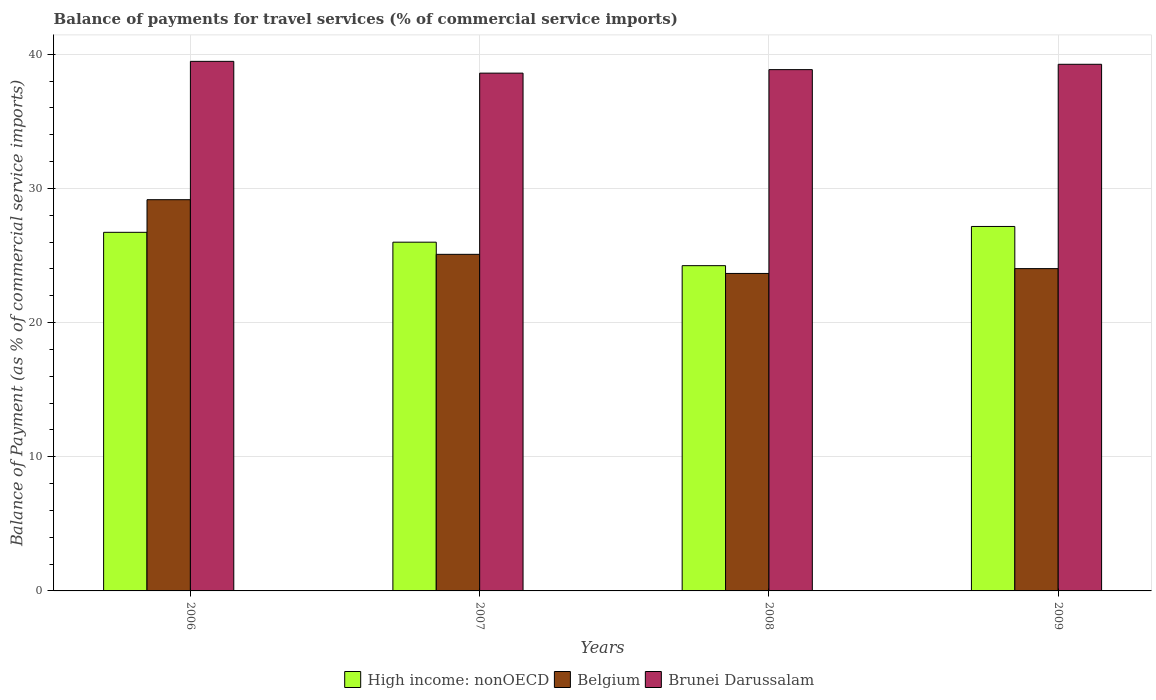How many different coloured bars are there?
Offer a terse response. 3. Are the number of bars on each tick of the X-axis equal?
Provide a succinct answer. Yes. How many bars are there on the 2nd tick from the right?
Make the answer very short. 3. What is the label of the 2nd group of bars from the left?
Keep it short and to the point. 2007. What is the balance of payments for travel services in Belgium in 2006?
Provide a succinct answer. 29.16. Across all years, what is the maximum balance of payments for travel services in High income: nonOECD?
Your answer should be very brief. 27.17. Across all years, what is the minimum balance of payments for travel services in Belgium?
Your response must be concise. 23.66. In which year was the balance of payments for travel services in Belgium minimum?
Your answer should be very brief. 2008. What is the total balance of payments for travel services in Brunei Darussalam in the graph?
Offer a very short reply. 156.18. What is the difference between the balance of payments for travel services in Brunei Darussalam in 2008 and that in 2009?
Your response must be concise. -0.4. What is the difference between the balance of payments for travel services in Belgium in 2008 and the balance of payments for travel services in Brunei Darussalam in 2009?
Keep it short and to the point. -15.59. What is the average balance of payments for travel services in Belgium per year?
Your answer should be compact. 25.48. In the year 2008, what is the difference between the balance of payments for travel services in Belgium and balance of payments for travel services in Brunei Darussalam?
Your answer should be compact. -15.19. What is the ratio of the balance of payments for travel services in Belgium in 2008 to that in 2009?
Offer a terse response. 0.99. Is the balance of payments for travel services in High income: nonOECD in 2007 less than that in 2009?
Offer a terse response. Yes. Is the difference between the balance of payments for travel services in Belgium in 2006 and 2009 greater than the difference between the balance of payments for travel services in Brunei Darussalam in 2006 and 2009?
Ensure brevity in your answer.  Yes. What is the difference between the highest and the second highest balance of payments for travel services in Brunei Darussalam?
Your answer should be very brief. 0.22. What is the difference between the highest and the lowest balance of payments for travel services in Brunei Darussalam?
Provide a succinct answer. 0.88. In how many years, is the balance of payments for travel services in High income: nonOECD greater than the average balance of payments for travel services in High income: nonOECD taken over all years?
Ensure brevity in your answer.  2. What does the 1st bar from the left in 2007 represents?
Your response must be concise. High income: nonOECD. What does the 3rd bar from the right in 2008 represents?
Provide a succinct answer. High income: nonOECD. Is it the case that in every year, the sum of the balance of payments for travel services in Brunei Darussalam and balance of payments for travel services in High income: nonOECD is greater than the balance of payments for travel services in Belgium?
Offer a very short reply. Yes. Are all the bars in the graph horizontal?
Ensure brevity in your answer.  No. How many years are there in the graph?
Give a very brief answer. 4. Where does the legend appear in the graph?
Keep it short and to the point. Bottom center. How many legend labels are there?
Provide a short and direct response. 3. What is the title of the graph?
Give a very brief answer. Balance of payments for travel services (% of commercial service imports). Does "Central African Republic" appear as one of the legend labels in the graph?
Give a very brief answer. No. What is the label or title of the Y-axis?
Your answer should be compact. Balance of Payment (as % of commercial service imports). What is the Balance of Payment (as % of commercial service imports) in High income: nonOECD in 2006?
Offer a very short reply. 26.73. What is the Balance of Payment (as % of commercial service imports) in Belgium in 2006?
Keep it short and to the point. 29.16. What is the Balance of Payment (as % of commercial service imports) of Brunei Darussalam in 2006?
Your response must be concise. 39.47. What is the Balance of Payment (as % of commercial service imports) of High income: nonOECD in 2007?
Give a very brief answer. 25.99. What is the Balance of Payment (as % of commercial service imports) in Belgium in 2007?
Your answer should be very brief. 25.09. What is the Balance of Payment (as % of commercial service imports) of Brunei Darussalam in 2007?
Your answer should be compact. 38.59. What is the Balance of Payment (as % of commercial service imports) of High income: nonOECD in 2008?
Give a very brief answer. 24.24. What is the Balance of Payment (as % of commercial service imports) in Belgium in 2008?
Your response must be concise. 23.66. What is the Balance of Payment (as % of commercial service imports) of Brunei Darussalam in 2008?
Your response must be concise. 38.86. What is the Balance of Payment (as % of commercial service imports) in High income: nonOECD in 2009?
Your response must be concise. 27.17. What is the Balance of Payment (as % of commercial service imports) of Belgium in 2009?
Give a very brief answer. 24.02. What is the Balance of Payment (as % of commercial service imports) of Brunei Darussalam in 2009?
Offer a very short reply. 39.25. Across all years, what is the maximum Balance of Payment (as % of commercial service imports) in High income: nonOECD?
Make the answer very short. 27.17. Across all years, what is the maximum Balance of Payment (as % of commercial service imports) in Belgium?
Your answer should be very brief. 29.16. Across all years, what is the maximum Balance of Payment (as % of commercial service imports) of Brunei Darussalam?
Provide a short and direct response. 39.47. Across all years, what is the minimum Balance of Payment (as % of commercial service imports) in High income: nonOECD?
Give a very brief answer. 24.24. Across all years, what is the minimum Balance of Payment (as % of commercial service imports) in Belgium?
Keep it short and to the point. 23.66. Across all years, what is the minimum Balance of Payment (as % of commercial service imports) of Brunei Darussalam?
Your answer should be compact. 38.59. What is the total Balance of Payment (as % of commercial service imports) in High income: nonOECD in the graph?
Your answer should be compact. 104.13. What is the total Balance of Payment (as % of commercial service imports) in Belgium in the graph?
Ensure brevity in your answer.  101.94. What is the total Balance of Payment (as % of commercial service imports) in Brunei Darussalam in the graph?
Your response must be concise. 156.18. What is the difference between the Balance of Payment (as % of commercial service imports) of High income: nonOECD in 2006 and that in 2007?
Keep it short and to the point. 0.74. What is the difference between the Balance of Payment (as % of commercial service imports) of Belgium in 2006 and that in 2007?
Your answer should be compact. 4.07. What is the difference between the Balance of Payment (as % of commercial service imports) of Brunei Darussalam in 2006 and that in 2007?
Ensure brevity in your answer.  0.88. What is the difference between the Balance of Payment (as % of commercial service imports) in High income: nonOECD in 2006 and that in 2008?
Ensure brevity in your answer.  2.48. What is the difference between the Balance of Payment (as % of commercial service imports) of Belgium in 2006 and that in 2008?
Make the answer very short. 5.5. What is the difference between the Balance of Payment (as % of commercial service imports) of Brunei Darussalam in 2006 and that in 2008?
Provide a short and direct response. 0.62. What is the difference between the Balance of Payment (as % of commercial service imports) in High income: nonOECD in 2006 and that in 2009?
Make the answer very short. -0.44. What is the difference between the Balance of Payment (as % of commercial service imports) of Belgium in 2006 and that in 2009?
Offer a very short reply. 5.14. What is the difference between the Balance of Payment (as % of commercial service imports) in Brunei Darussalam in 2006 and that in 2009?
Make the answer very short. 0.22. What is the difference between the Balance of Payment (as % of commercial service imports) in High income: nonOECD in 2007 and that in 2008?
Make the answer very short. 1.75. What is the difference between the Balance of Payment (as % of commercial service imports) of Belgium in 2007 and that in 2008?
Keep it short and to the point. 1.42. What is the difference between the Balance of Payment (as % of commercial service imports) in Brunei Darussalam in 2007 and that in 2008?
Your answer should be very brief. -0.26. What is the difference between the Balance of Payment (as % of commercial service imports) of High income: nonOECD in 2007 and that in 2009?
Keep it short and to the point. -1.17. What is the difference between the Balance of Payment (as % of commercial service imports) in Belgium in 2007 and that in 2009?
Give a very brief answer. 1.06. What is the difference between the Balance of Payment (as % of commercial service imports) of Brunei Darussalam in 2007 and that in 2009?
Ensure brevity in your answer.  -0.66. What is the difference between the Balance of Payment (as % of commercial service imports) in High income: nonOECD in 2008 and that in 2009?
Your answer should be very brief. -2.92. What is the difference between the Balance of Payment (as % of commercial service imports) of Belgium in 2008 and that in 2009?
Provide a short and direct response. -0.36. What is the difference between the Balance of Payment (as % of commercial service imports) of Brunei Darussalam in 2008 and that in 2009?
Offer a terse response. -0.4. What is the difference between the Balance of Payment (as % of commercial service imports) of High income: nonOECD in 2006 and the Balance of Payment (as % of commercial service imports) of Belgium in 2007?
Your answer should be compact. 1.64. What is the difference between the Balance of Payment (as % of commercial service imports) in High income: nonOECD in 2006 and the Balance of Payment (as % of commercial service imports) in Brunei Darussalam in 2007?
Your response must be concise. -11.87. What is the difference between the Balance of Payment (as % of commercial service imports) in Belgium in 2006 and the Balance of Payment (as % of commercial service imports) in Brunei Darussalam in 2007?
Ensure brevity in your answer.  -9.43. What is the difference between the Balance of Payment (as % of commercial service imports) in High income: nonOECD in 2006 and the Balance of Payment (as % of commercial service imports) in Belgium in 2008?
Offer a very short reply. 3.07. What is the difference between the Balance of Payment (as % of commercial service imports) of High income: nonOECD in 2006 and the Balance of Payment (as % of commercial service imports) of Brunei Darussalam in 2008?
Your answer should be compact. -12.13. What is the difference between the Balance of Payment (as % of commercial service imports) of Belgium in 2006 and the Balance of Payment (as % of commercial service imports) of Brunei Darussalam in 2008?
Provide a short and direct response. -9.69. What is the difference between the Balance of Payment (as % of commercial service imports) of High income: nonOECD in 2006 and the Balance of Payment (as % of commercial service imports) of Belgium in 2009?
Provide a succinct answer. 2.71. What is the difference between the Balance of Payment (as % of commercial service imports) in High income: nonOECD in 2006 and the Balance of Payment (as % of commercial service imports) in Brunei Darussalam in 2009?
Your answer should be compact. -12.53. What is the difference between the Balance of Payment (as % of commercial service imports) in Belgium in 2006 and the Balance of Payment (as % of commercial service imports) in Brunei Darussalam in 2009?
Keep it short and to the point. -10.09. What is the difference between the Balance of Payment (as % of commercial service imports) in High income: nonOECD in 2007 and the Balance of Payment (as % of commercial service imports) in Belgium in 2008?
Your response must be concise. 2.33. What is the difference between the Balance of Payment (as % of commercial service imports) of High income: nonOECD in 2007 and the Balance of Payment (as % of commercial service imports) of Brunei Darussalam in 2008?
Ensure brevity in your answer.  -12.86. What is the difference between the Balance of Payment (as % of commercial service imports) of Belgium in 2007 and the Balance of Payment (as % of commercial service imports) of Brunei Darussalam in 2008?
Your answer should be very brief. -13.77. What is the difference between the Balance of Payment (as % of commercial service imports) of High income: nonOECD in 2007 and the Balance of Payment (as % of commercial service imports) of Belgium in 2009?
Give a very brief answer. 1.97. What is the difference between the Balance of Payment (as % of commercial service imports) in High income: nonOECD in 2007 and the Balance of Payment (as % of commercial service imports) in Brunei Darussalam in 2009?
Ensure brevity in your answer.  -13.26. What is the difference between the Balance of Payment (as % of commercial service imports) of Belgium in 2007 and the Balance of Payment (as % of commercial service imports) of Brunei Darussalam in 2009?
Offer a very short reply. -14.17. What is the difference between the Balance of Payment (as % of commercial service imports) in High income: nonOECD in 2008 and the Balance of Payment (as % of commercial service imports) in Belgium in 2009?
Provide a succinct answer. 0.22. What is the difference between the Balance of Payment (as % of commercial service imports) of High income: nonOECD in 2008 and the Balance of Payment (as % of commercial service imports) of Brunei Darussalam in 2009?
Offer a very short reply. -15.01. What is the difference between the Balance of Payment (as % of commercial service imports) of Belgium in 2008 and the Balance of Payment (as % of commercial service imports) of Brunei Darussalam in 2009?
Provide a succinct answer. -15.59. What is the average Balance of Payment (as % of commercial service imports) of High income: nonOECD per year?
Offer a terse response. 26.03. What is the average Balance of Payment (as % of commercial service imports) of Belgium per year?
Give a very brief answer. 25.48. What is the average Balance of Payment (as % of commercial service imports) in Brunei Darussalam per year?
Your answer should be very brief. 39.04. In the year 2006, what is the difference between the Balance of Payment (as % of commercial service imports) of High income: nonOECD and Balance of Payment (as % of commercial service imports) of Belgium?
Ensure brevity in your answer.  -2.43. In the year 2006, what is the difference between the Balance of Payment (as % of commercial service imports) of High income: nonOECD and Balance of Payment (as % of commercial service imports) of Brunei Darussalam?
Your answer should be very brief. -12.74. In the year 2006, what is the difference between the Balance of Payment (as % of commercial service imports) in Belgium and Balance of Payment (as % of commercial service imports) in Brunei Darussalam?
Keep it short and to the point. -10.31. In the year 2007, what is the difference between the Balance of Payment (as % of commercial service imports) in High income: nonOECD and Balance of Payment (as % of commercial service imports) in Belgium?
Provide a succinct answer. 0.91. In the year 2007, what is the difference between the Balance of Payment (as % of commercial service imports) of High income: nonOECD and Balance of Payment (as % of commercial service imports) of Brunei Darussalam?
Provide a succinct answer. -12.6. In the year 2007, what is the difference between the Balance of Payment (as % of commercial service imports) in Belgium and Balance of Payment (as % of commercial service imports) in Brunei Darussalam?
Ensure brevity in your answer.  -13.51. In the year 2008, what is the difference between the Balance of Payment (as % of commercial service imports) in High income: nonOECD and Balance of Payment (as % of commercial service imports) in Belgium?
Offer a terse response. 0.58. In the year 2008, what is the difference between the Balance of Payment (as % of commercial service imports) in High income: nonOECD and Balance of Payment (as % of commercial service imports) in Brunei Darussalam?
Ensure brevity in your answer.  -14.61. In the year 2008, what is the difference between the Balance of Payment (as % of commercial service imports) of Belgium and Balance of Payment (as % of commercial service imports) of Brunei Darussalam?
Offer a very short reply. -15.19. In the year 2009, what is the difference between the Balance of Payment (as % of commercial service imports) in High income: nonOECD and Balance of Payment (as % of commercial service imports) in Belgium?
Make the answer very short. 3.14. In the year 2009, what is the difference between the Balance of Payment (as % of commercial service imports) in High income: nonOECD and Balance of Payment (as % of commercial service imports) in Brunei Darussalam?
Make the answer very short. -12.09. In the year 2009, what is the difference between the Balance of Payment (as % of commercial service imports) in Belgium and Balance of Payment (as % of commercial service imports) in Brunei Darussalam?
Ensure brevity in your answer.  -15.23. What is the ratio of the Balance of Payment (as % of commercial service imports) in High income: nonOECD in 2006 to that in 2007?
Offer a very short reply. 1.03. What is the ratio of the Balance of Payment (as % of commercial service imports) of Belgium in 2006 to that in 2007?
Offer a terse response. 1.16. What is the ratio of the Balance of Payment (as % of commercial service imports) in Brunei Darussalam in 2006 to that in 2007?
Provide a succinct answer. 1.02. What is the ratio of the Balance of Payment (as % of commercial service imports) in High income: nonOECD in 2006 to that in 2008?
Offer a terse response. 1.1. What is the ratio of the Balance of Payment (as % of commercial service imports) of Belgium in 2006 to that in 2008?
Provide a short and direct response. 1.23. What is the ratio of the Balance of Payment (as % of commercial service imports) in Brunei Darussalam in 2006 to that in 2008?
Offer a terse response. 1.02. What is the ratio of the Balance of Payment (as % of commercial service imports) in High income: nonOECD in 2006 to that in 2009?
Keep it short and to the point. 0.98. What is the ratio of the Balance of Payment (as % of commercial service imports) of Belgium in 2006 to that in 2009?
Your answer should be very brief. 1.21. What is the ratio of the Balance of Payment (as % of commercial service imports) in Brunei Darussalam in 2006 to that in 2009?
Your answer should be compact. 1.01. What is the ratio of the Balance of Payment (as % of commercial service imports) of High income: nonOECD in 2007 to that in 2008?
Provide a short and direct response. 1.07. What is the ratio of the Balance of Payment (as % of commercial service imports) of Belgium in 2007 to that in 2008?
Make the answer very short. 1.06. What is the ratio of the Balance of Payment (as % of commercial service imports) in Brunei Darussalam in 2007 to that in 2008?
Your response must be concise. 0.99. What is the ratio of the Balance of Payment (as % of commercial service imports) in High income: nonOECD in 2007 to that in 2009?
Your answer should be very brief. 0.96. What is the ratio of the Balance of Payment (as % of commercial service imports) of Belgium in 2007 to that in 2009?
Your answer should be compact. 1.04. What is the ratio of the Balance of Payment (as % of commercial service imports) in Brunei Darussalam in 2007 to that in 2009?
Your answer should be very brief. 0.98. What is the ratio of the Balance of Payment (as % of commercial service imports) in High income: nonOECD in 2008 to that in 2009?
Your answer should be compact. 0.89. What is the ratio of the Balance of Payment (as % of commercial service imports) in Brunei Darussalam in 2008 to that in 2009?
Your answer should be very brief. 0.99. What is the difference between the highest and the second highest Balance of Payment (as % of commercial service imports) in High income: nonOECD?
Give a very brief answer. 0.44. What is the difference between the highest and the second highest Balance of Payment (as % of commercial service imports) in Belgium?
Make the answer very short. 4.07. What is the difference between the highest and the second highest Balance of Payment (as % of commercial service imports) in Brunei Darussalam?
Your answer should be very brief. 0.22. What is the difference between the highest and the lowest Balance of Payment (as % of commercial service imports) of High income: nonOECD?
Ensure brevity in your answer.  2.92. What is the difference between the highest and the lowest Balance of Payment (as % of commercial service imports) of Belgium?
Your answer should be very brief. 5.5. What is the difference between the highest and the lowest Balance of Payment (as % of commercial service imports) in Brunei Darussalam?
Your response must be concise. 0.88. 